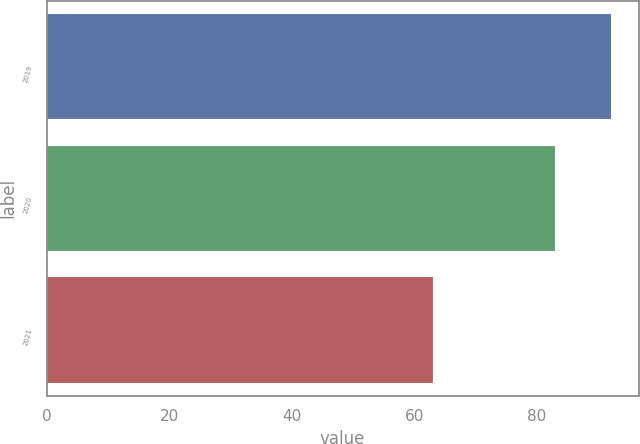<chart> <loc_0><loc_0><loc_500><loc_500><bar_chart><fcel>2019<fcel>2020<fcel>2021<nl><fcel>92<fcel>83<fcel>63<nl></chart> 